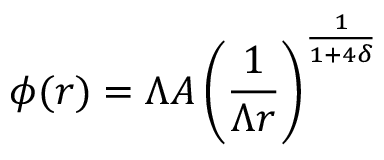<formula> <loc_0><loc_0><loc_500><loc_500>\phi ( r ) = \Lambda A \left ( \frac { 1 } { \Lambda r } \right ) ^ { \frac { 1 } { 1 + 4 \delta } }</formula> 